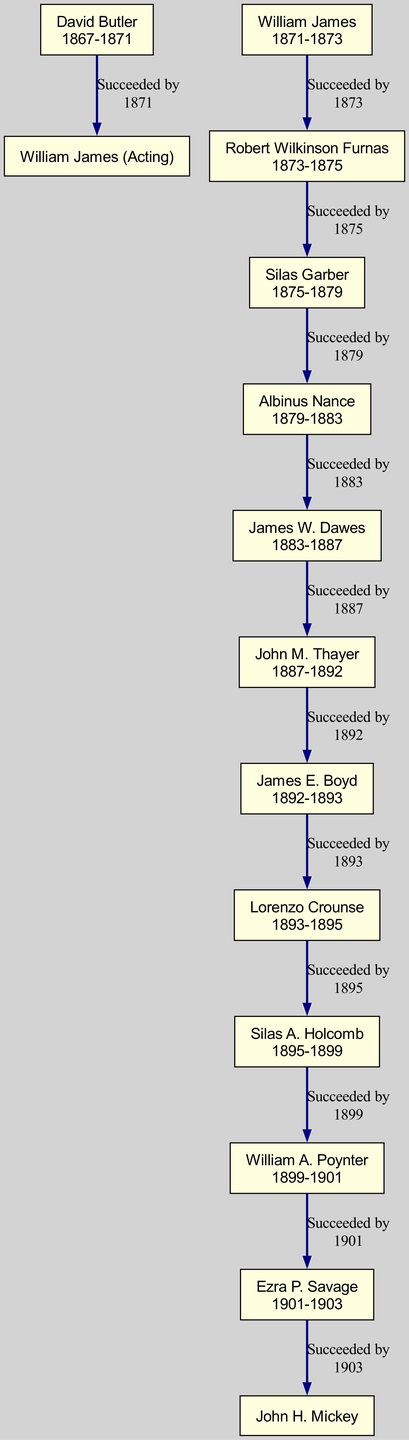What is the term duration of Albinus Nance? Albinus Nance served as Governor from 1879 to 1883, which gives him a term duration of four years.
Answer: 1879-1883 Who succeeded James E. Boyd? The diagram shows that James E. Boyd was succeeded by Lorenzo Crounse, with an arrow indicating the succession relationship.
Answer: Lorenzo Crounse How many governors served before Silas Garber? By counting the governors listed prior to Silas Garber's name, we see there are six governors (David Butler, William James, Robert Wilkinson Furnas, Albinus Nance, James W. Dawes, and John M. Thayer).
Answer: 6 What year did John M. Thayer's term start? The diagram indicates that John M. Thayer’s term as governor started in 1887, as shown next to his name.
Answer: 1887 Which governor served the longest term between David Butler and James W. Dawes? Comparing the term lengths, David Butler served from 1867 to 1871 (4 years) and James W. Dawes from 1883 to 1887 (4 years), thus they both had equal term durations.
Answer: Equal (4 years each) What is the total number of governors listed in the diagram? The diagram features a total of 13 governors listed, so you count each one in the “Governors” section.
Answer: 13 Which governor's term ended immediately before Ezra P. Savage's term started? The diagram indicates that William A. Poynter’s term ended in 1901, which was right before Ezra P. Savage began his term.
Answer: William A. Poynter Who was the acting governor before William James? According to the diagram, David Butler was the governor before William James, indicated by the flow from Butler to James.
Answer: David Butler 